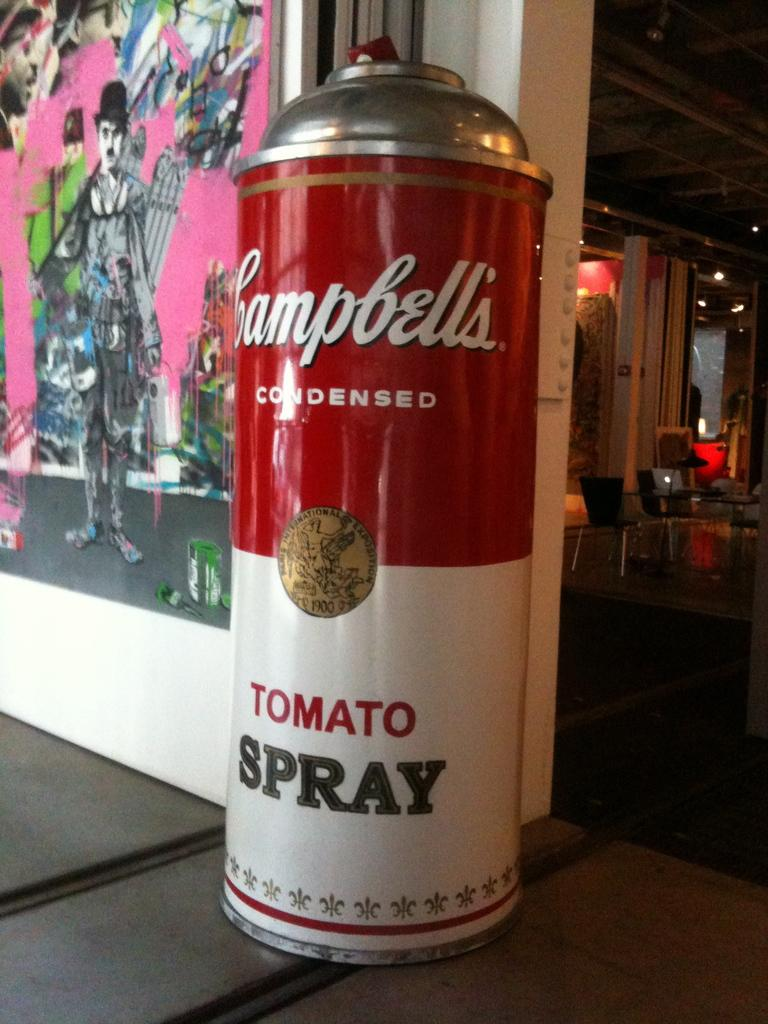What is the main object in the picture? There is a big can in the picture. Where is the can located in relation to other objects? The can is near a painting. What can be seen in the right background of the picture? There is a table, chairs, lamps, a light, a door, and other objects in the right background of the picture. What does the can taste like in the image? The image does not provide any information about the taste of the can, as it is a visual representation and does not convey taste. Can you see a ray of light coming from the door in the image? There is no mention of a ray of light coming from the door in the provided facts, and the image does not show any such detail. 